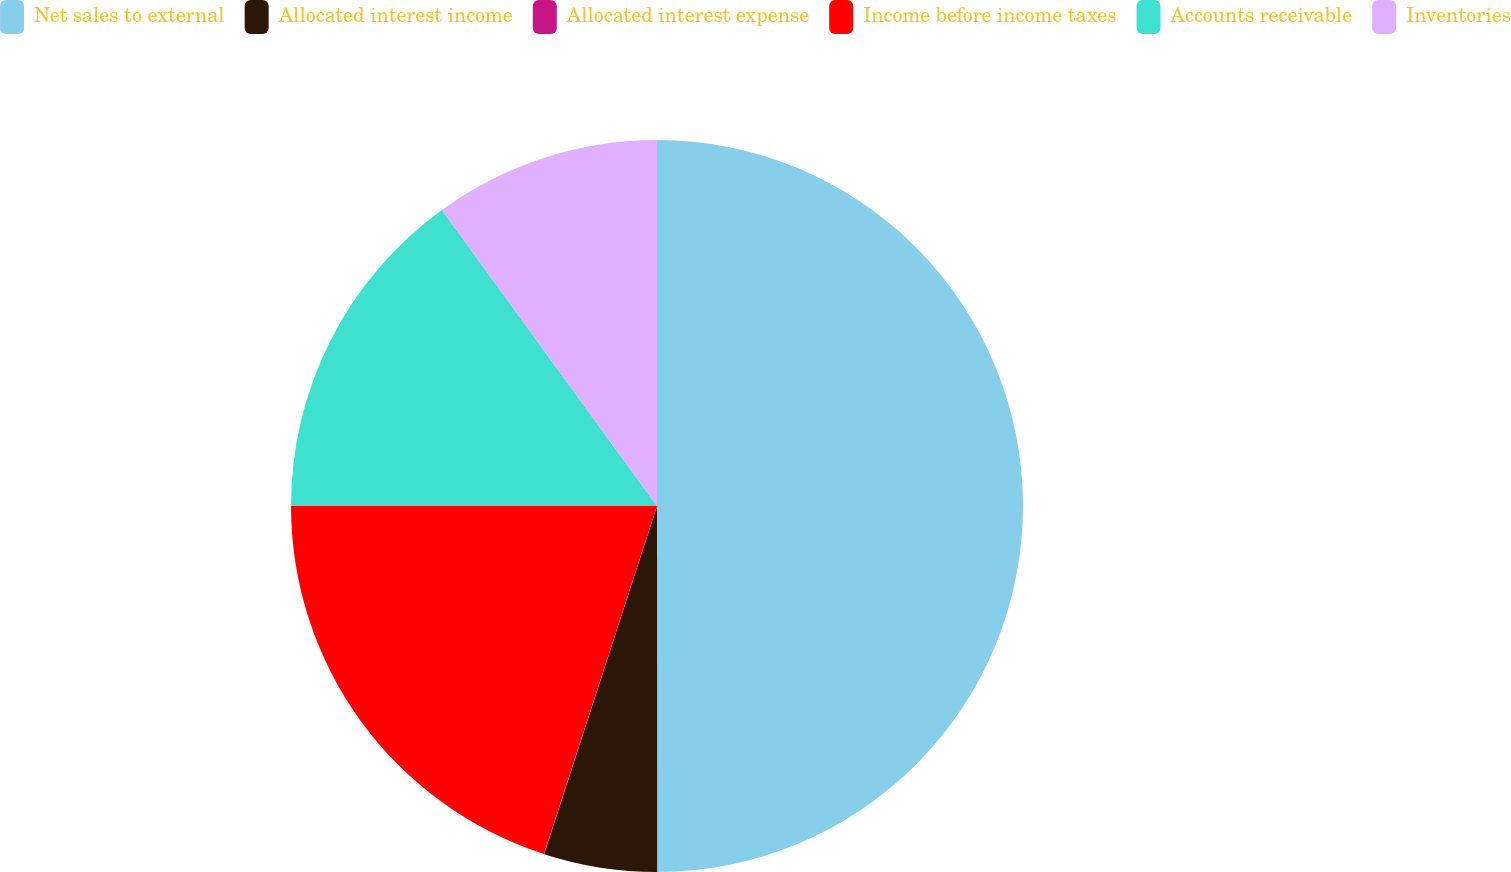Convert chart. <chart><loc_0><loc_0><loc_500><loc_500><pie_chart><fcel>Net sales to external<fcel>Allocated interest income<fcel>Allocated interest expense<fcel>Income before income taxes<fcel>Accounts receivable<fcel>Inventories<nl><fcel>49.99%<fcel>5.0%<fcel>0.01%<fcel>20.0%<fcel>15.0%<fcel>10.0%<nl></chart> 